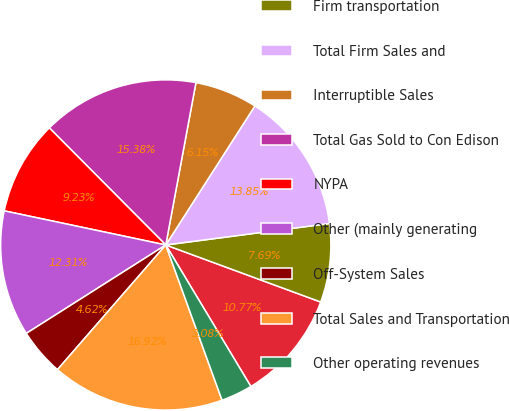Convert chart. <chart><loc_0><loc_0><loc_500><loc_500><pie_chart><fcel>Full service<fcel>Firm transportation<fcel>Total Firm Sales and<fcel>Interruptible Sales<fcel>Total Gas Sold to Con Edison<fcel>NYPA<fcel>Other (mainly generating<fcel>Off-System Sales<fcel>Total Sales and Transportation<fcel>Other operating revenues<nl><fcel>10.77%<fcel>7.69%<fcel>13.85%<fcel>6.15%<fcel>15.38%<fcel>9.23%<fcel>12.31%<fcel>4.62%<fcel>16.92%<fcel>3.08%<nl></chart> 